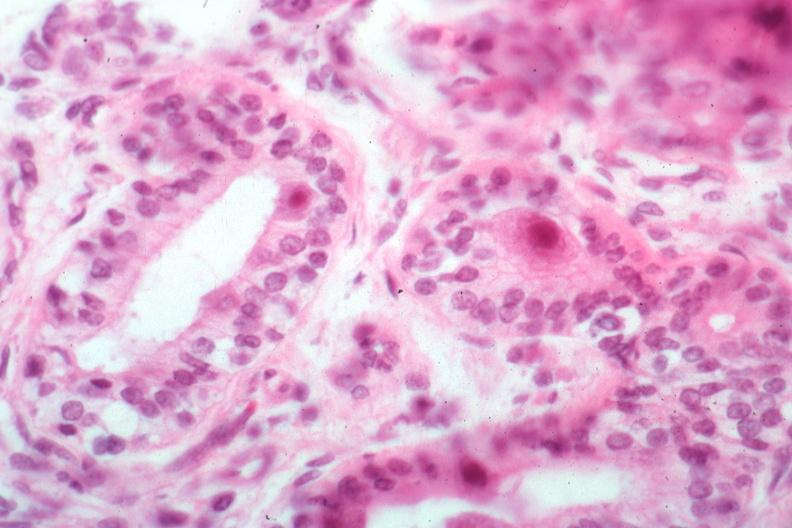s sectioned femur lesion present?
Answer the question using a single word or phrase. No 